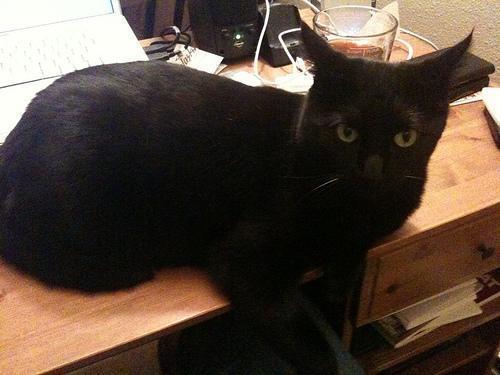What type of woman might this animal be associated with historically?
Make your selection from the four choices given to correctly answer the question.
Options: Wetnurse, midwife, witch, nurse. Witch. 